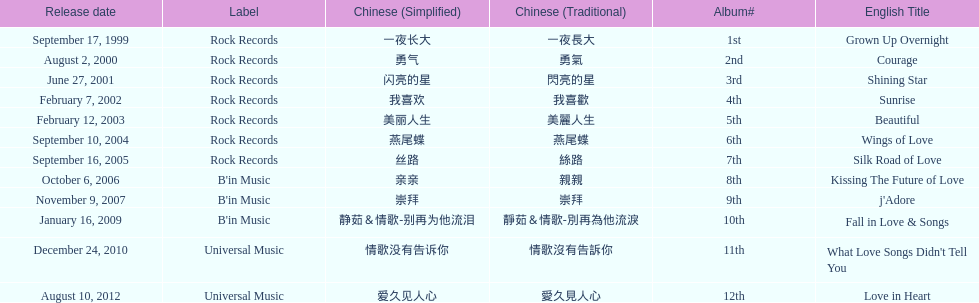Which english titles were released during even years? Courage, Sunrise, Silk Road of Love, Kissing The Future of Love, What Love Songs Didn't Tell You, Love in Heart. Out of the following, which one was released under b's in music? Kissing The Future of Love. Parse the full table. {'header': ['Release date', 'Label', 'Chinese (Simplified)', 'Chinese (Traditional)', 'Album#', 'English Title'], 'rows': [['September 17, 1999', 'Rock Records', '一夜长大', '一夜長大', '1st', 'Grown Up Overnight'], ['August 2, 2000', 'Rock Records', '勇气', '勇氣', '2nd', 'Courage'], ['June 27, 2001', 'Rock Records', '闪亮的星', '閃亮的星', '3rd', 'Shining Star'], ['February 7, 2002', 'Rock Records', '我喜欢', '我喜歡', '4th', 'Sunrise'], ['February 12, 2003', 'Rock Records', '美丽人生', '美麗人生', '5th', 'Beautiful'], ['September 10, 2004', 'Rock Records', '燕尾蝶', '燕尾蝶', '6th', 'Wings of Love'], ['September 16, 2005', 'Rock Records', '丝路', '絲路', '7th', 'Silk Road of Love'], ['October 6, 2006', "B'in Music", '亲亲', '親親', '8th', 'Kissing The Future of Love'], ['November 9, 2007', "B'in Music", '崇拜', '崇拜', '9th', "j'Adore"], ['January 16, 2009', "B'in Music", '静茹＆情歌-别再为他流泪', '靜茹＆情歌-別再為他流淚', '10th', 'Fall in Love & Songs'], ['December 24, 2010', 'Universal Music', '情歌没有告诉你', '情歌沒有告訴你', '11th', "What Love Songs Didn't Tell You"], ['August 10, 2012', 'Universal Music', '爱久见人心', '愛久見人心', '12th', 'Love in Heart']]} 